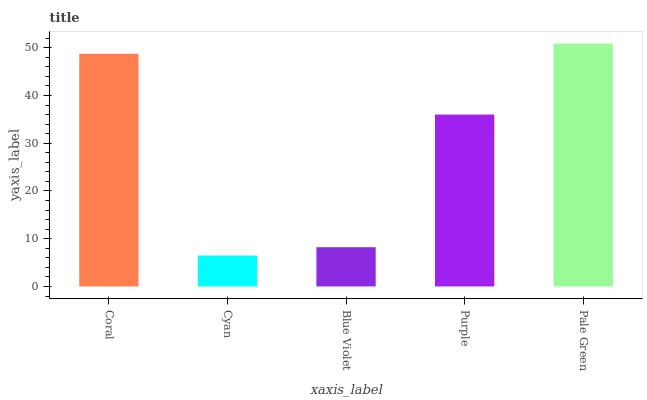Is Cyan the minimum?
Answer yes or no. Yes. Is Pale Green the maximum?
Answer yes or no. Yes. Is Blue Violet the minimum?
Answer yes or no. No. Is Blue Violet the maximum?
Answer yes or no. No. Is Blue Violet greater than Cyan?
Answer yes or no. Yes. Is Cyan less than Blue Violet?
Answer yes or no. Yes. Is Cyan greater than Blue Violet?
Answer yes or no. No. Is Blue Violet less than Cyan?
Answer yes or no. No. Is Purple the high median?
Answer yes or no. Yes. Is Purple the low median?
Answer yes or no. Yes. Is Blue Violet the high median?
Answer yes or no. No. Is Coral the low median?
Answer yes or no. No. 